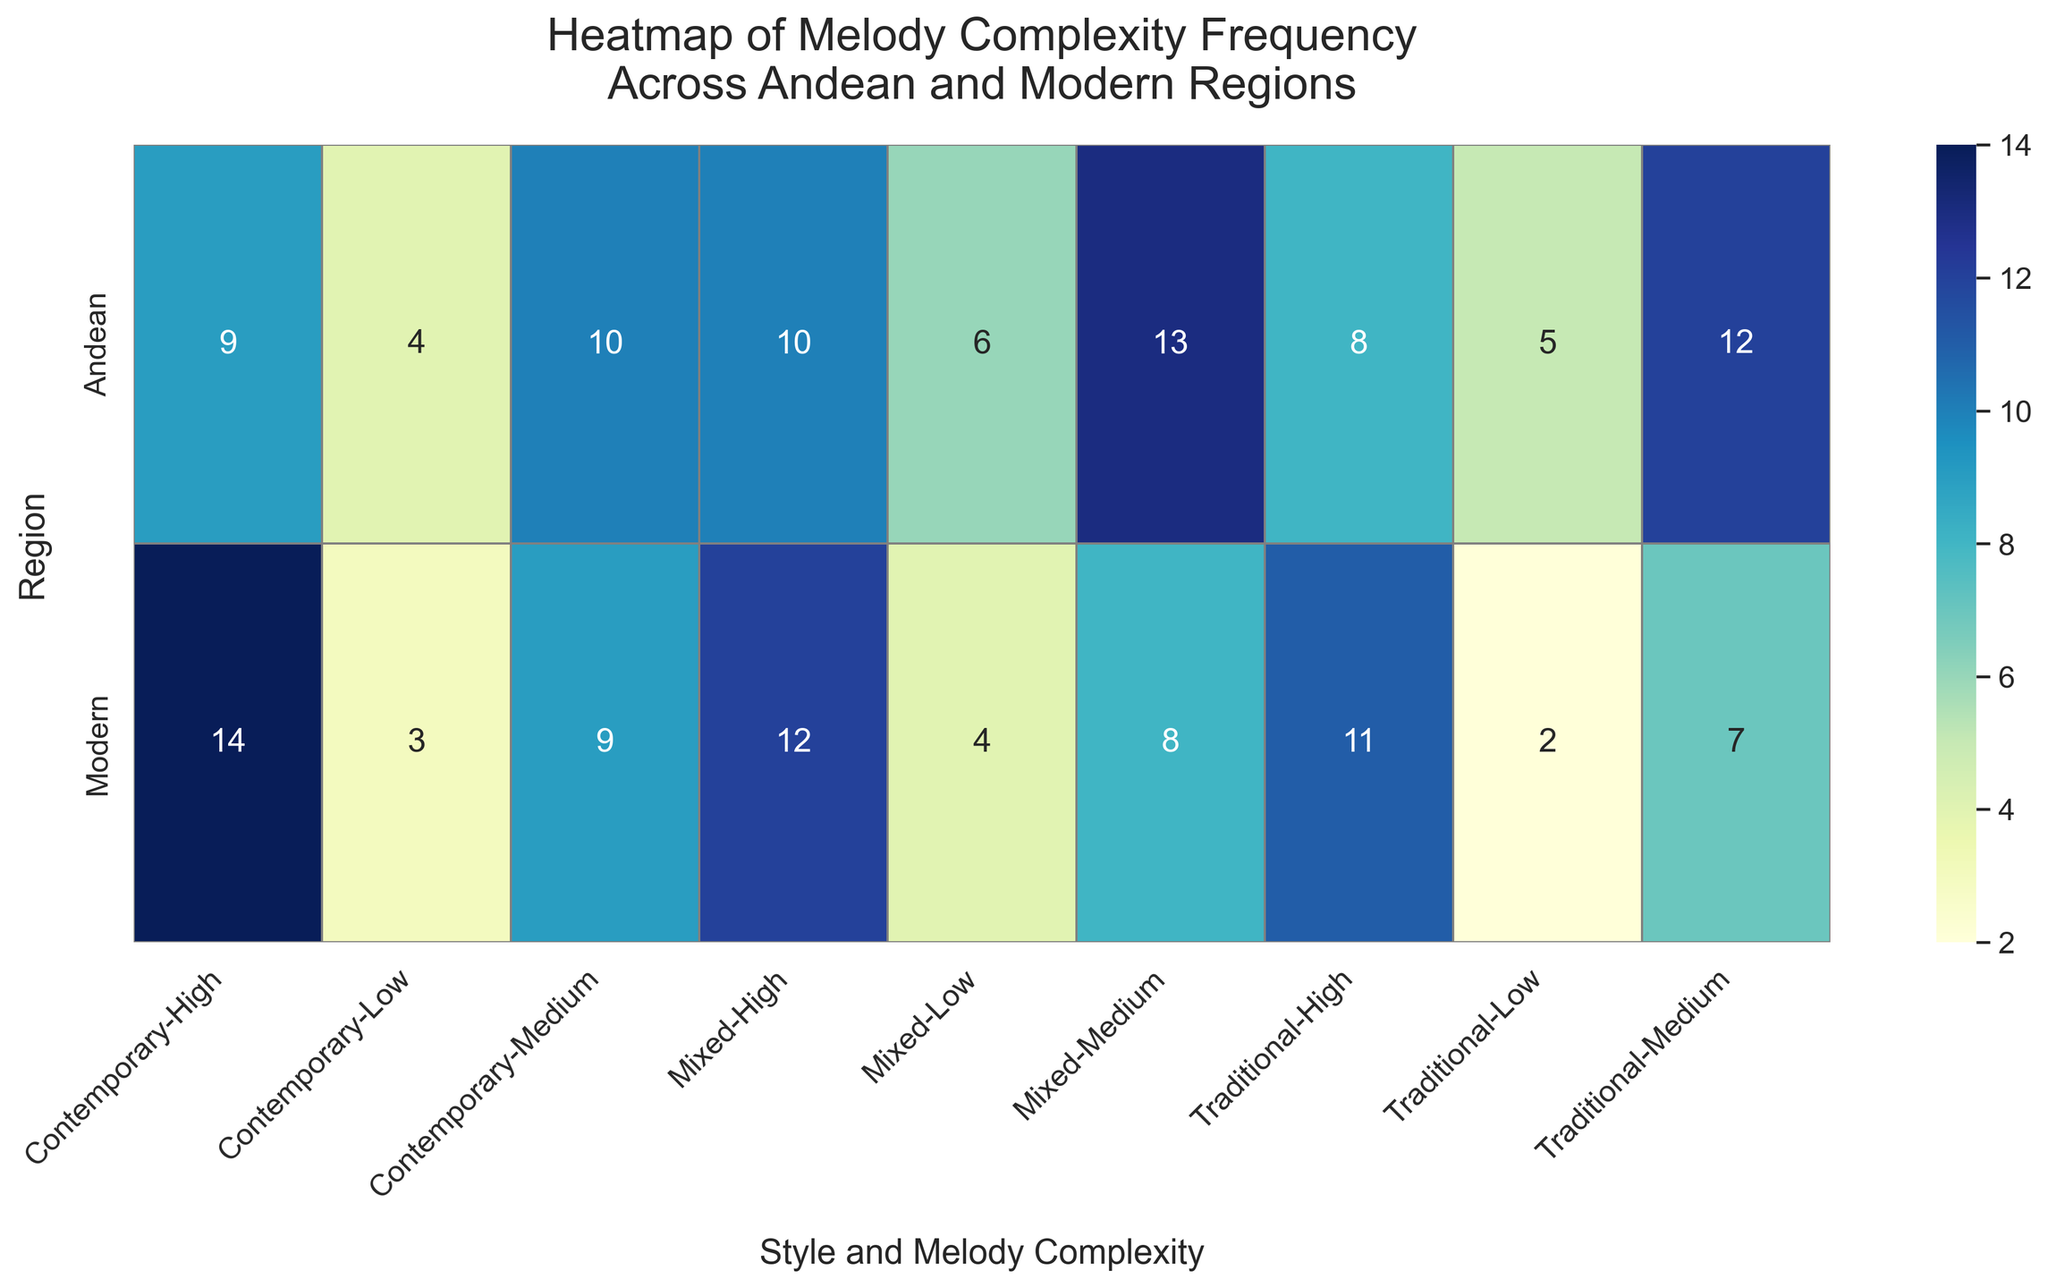What's the most common melody complexity in Traditional Andean style? Look at the 'Traditional' column under the 'Andean' row, find the highest frequency.
Answer: Medium Which region has a higher frequency of high melody complexity in Contemporary style? Compare the 'High' frequencies under 'Contemporary' for 'Andean' and 'Modern'. 'Andean' has 9, while 'Modern' has 14.
Answer: Modern If you combine all styles, which region has the highest total frequency for low melody complexity? Sum the 'Low' frequencies for each 'Style' under 'Andean' and 'Modern'. Andean: 5+4+6=15, Modern: 3+2+4=9.
Answer: Andean What's the frequency difference between medium and high melody complexity in Mixed style for Modern region? Find frequencies of 'Medium' and 'High' under 'Mixed' for 'Modern', then subtract: 12 - 8 = 4.
Answer: 4 How does the frequency of high melody complexity in Traditional Modern compare to that in Traditional Andean? Compare the 'High' frequencies under 'Traditional' for 'Modern' (11) and 'Andean' (8). 11 is greater than 8.
Answer: Modern has higher What's the most common melody complexity in Modern region across all styles? Sum the 'Low', 'Medium', 'High' frequencies for 'Modern' across 'Traditional', 'Contemporary', 'Mixed'. 'Medium': 7+9+8=24, 'High': 11+14+12=37, 'Low': 2+3+4=9. 'High' has the highest total.
Answer: High Compare the total frequency of medium melody complexity in Andean region across all styles with Modern region. Add 'Medium' frequencies in 'Traditional', 'Contemporary', 'Mixed' for both 'Andean' (12 + 10 + 13 = 35) and 'Modern' (7 + 9 + 8 = 24). Check which is higher.
Answer: Andean Which style and melody complexity combination has the lowest frequency in Modern region? Look for the smallest value under 'Modern' region for all combinations. The smallest value is 2 under 'Traditional Low'.
Answer: Traditional Low 